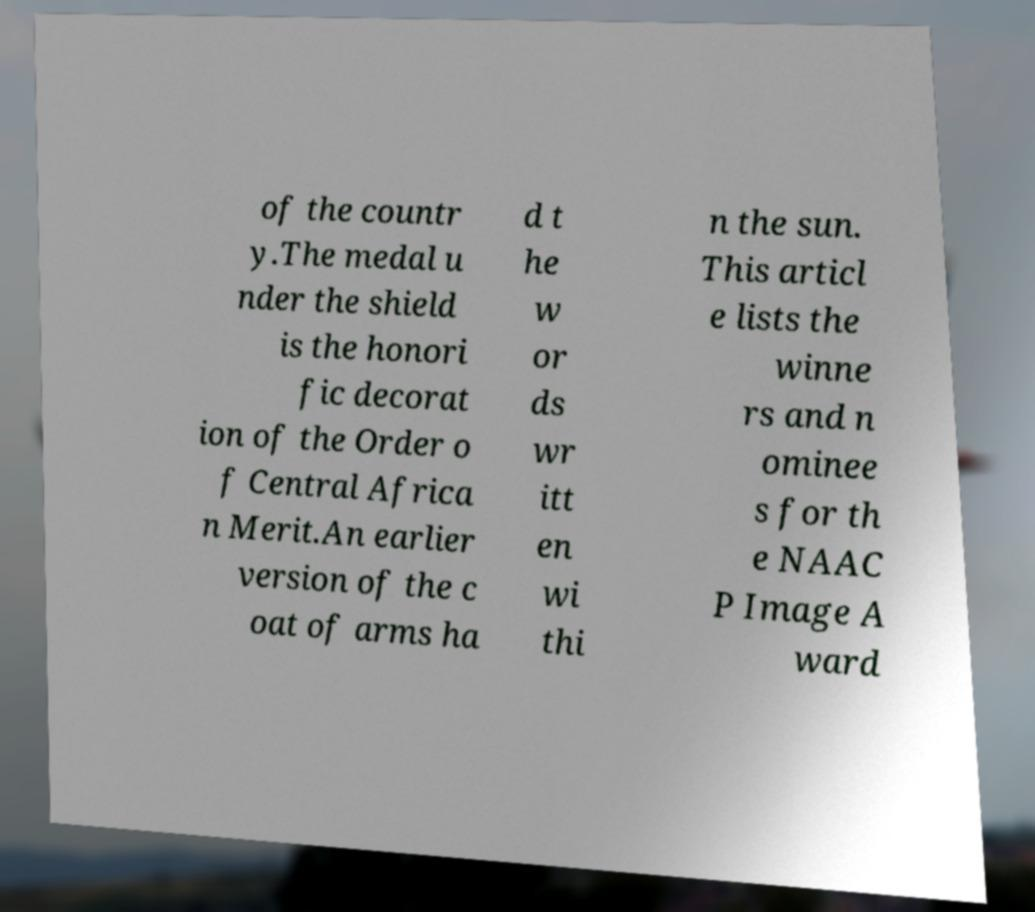Could you extract and type out the text from this image? of the countr y.The medal u nder the shield is the honori fic decorat ion of the Order o f Central Africa n Merit.An earlier version of the c oat of arms ha d t he w or ds wr itt en wi thi n the sun. This articl e lists the winne rs and n ominee s for th e NAAC P Image A ward 